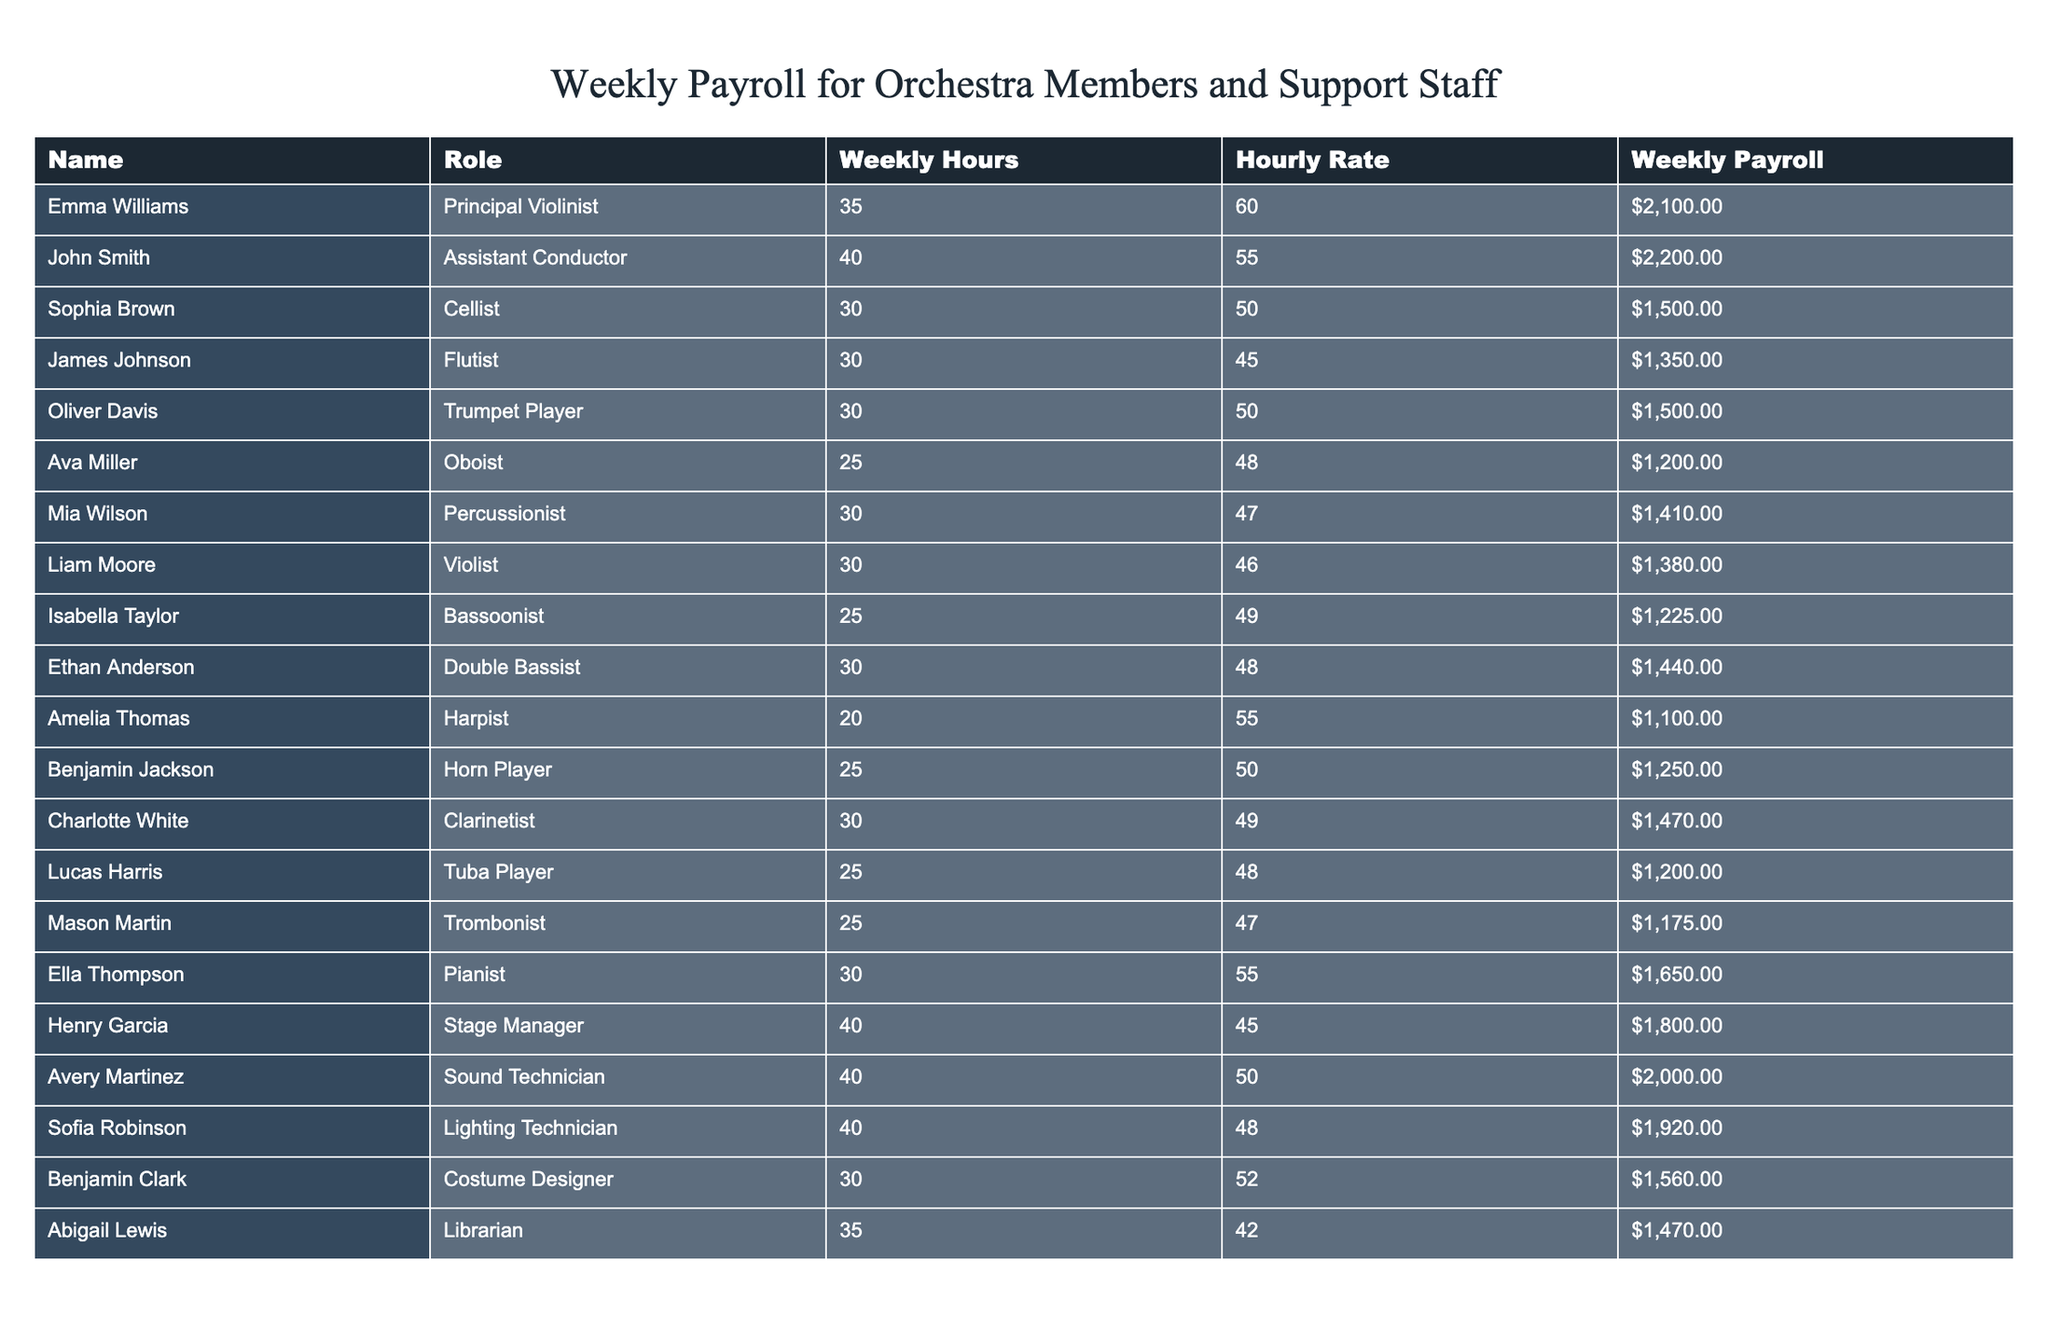What is the weekly payroll of the Assistant Conductor? The weekly payroll for the Assistant Conductor, John Smith, is directly found in the table under the "Weekly Payroll" column corresponding to his name. It states $2,200.
Answer: $2,200 How many hours does the Principal Violinist work per week? Emma Williams, the Principal Violinist, works 35 hours per week according to the "Weekly Hours" column in the table.
Answer: 35 hours Which orchestra member earns the least weekly payroll? To find this, I look through the "Weekly Payroll" column and identify the lowest value, which is $1,100 for Amelia Thomas, the Harpist.
Answer: $1,100 What is the average hourly rate of all the orchestra members? First, I sum up all the hourly rates: 60 + 55 + 50 + 45 + 50 + 48 + 47 + 46 + 49 + 48 + 55 + 50 + 48 + 52 + 42 = 679. Then, divide by 15 (the total number of members), which results in an average of approximately 45.27.
Answer: $45.27 Is there any member who works more than 40 hours a week? Upon reviewing the "Weekly Hours" column, I see both the Assistant Conductor and the Stage Manager work 40 hours, but no one exceeds that. Hence, the answer is no.
Answer: No Which support staff member has the highest weekly payroll? I need to check the "Weekly Payroll" column, and find that the highest amount among support staff (stage manager, sound technician, lighting technician, etc.) is $2,000 for Avery Martinez, the Sound Technician.
Answer: $2,000 How many members have a weekly payroll of over $1,500? I scan the "Weekly Payroll" column and find members with values greater than $1,500: Emma Williams, John Smith, Ella Thompson, Henry Garcia, Avery Martinez, Sofia Robinson, and Benjamin Clark, making a total of 7.
Answer: 7 What is the total weekly payroll for all members combined? I add up all the weekly payroll amounts listed in the table: $2,100 + $2,200 + $1,500 + $1,350 + $1,500 + $1,200 + $1,410 + $1,380 + $1,225 + $1,440 + $1,100 + $1,250 + $1,470 + $1,200 + $1,175 + $1,650 + $1,800 + $2,000 + $1,920 + $1,560 + $1,470 = $33,315.
Answer: $33,315 How many musicians have an hourly rate of less than $50? Looking through the "Hourly Rate" column, I find musicians with rates less than $50 include Ava Miller (48), James Johnson (45), and Oliver Davis (50), totaling 6 members with hourly rates below $50.
Answer: 6 